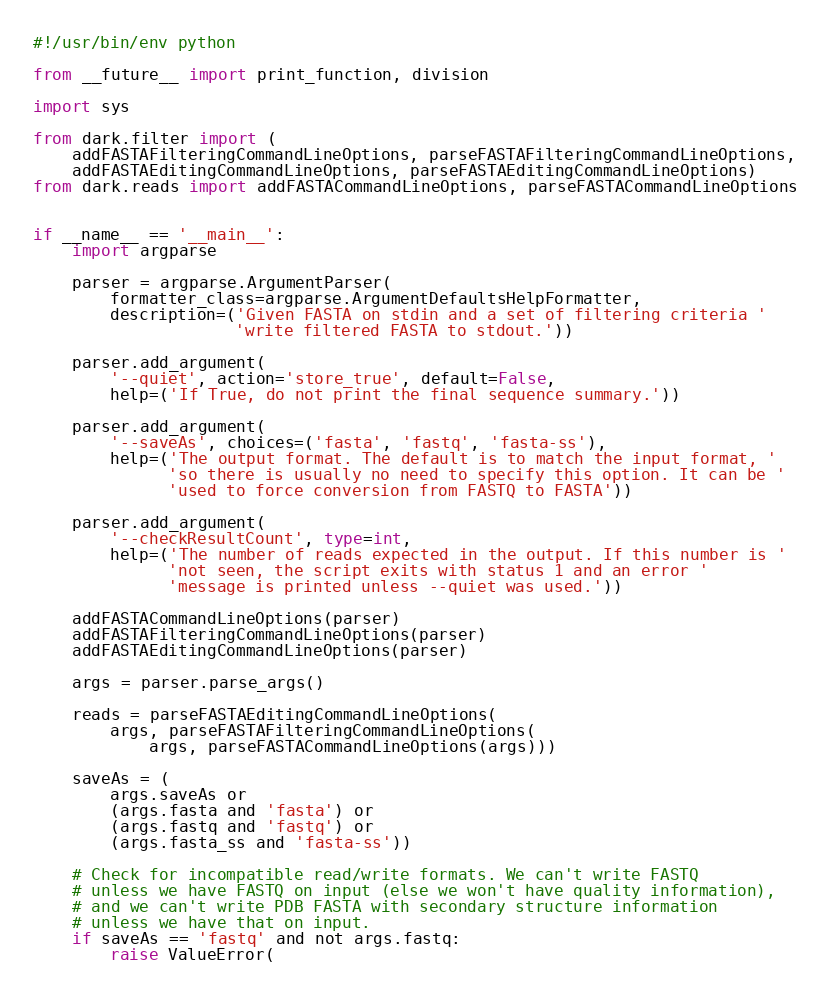<code> <loc_0><loc_0><loc_500><loc_500><_Python_>#!/usr/bin/env python

from __future__ import print_function, division

import sys

from dark.filter import (
    addFASTAFilteringCommandLineOptions, parseFASTAFilteringCommandLineOptions,
    addFASTAEditingCommandLineOptions, parseFASTAEditingCommandLineOptions)
from dark.reads import addFASTACommandLineOptions, parseFASTACommandLineOptions


if __name__ == '__main__':
    import argparse

    parser = argparse.ArgumentParser(
        formatter_class=argparse.ArgumentDefaultsHelpFormatter,
        description=('Given FASTA on stdin and a set of filtering criteria '
                     'write filtered FASTA to stdout.'))

    parser.add_argument(
        '--quiet', action='store_true', default=False,
        help=('If True, do not print the final sequence summary.'))

    parser.add_argument(
        '--saveAs', choices=('fasta', 'fastq', 'fasta-ss'),
        help=('The output format. The default is to match the input format, '
              'so there is usually no need to specify this option. It can be '
              'used to force conversion from FASTQ to FASTA'))

    parser.add_argument(
        '--checkResultCount', type=int,
        help=('The number of reads expected in the output. If this number is '
              'not seen, the script exits with status 1 and an error '
              'message is printed unless --quiet was used.'))

    addFASTACommandLineOptions(parser)
    addFASTAFilteringCommandLineOptions(parser)
    addFASTAEditingCommandLineOptions(parser)

    args = parser.parse_args()

    reads = parseFASTAEditingCommandLineOptions(
        args, parseFASTAFilteringCommandLineOptions(
            args, parseFASTACommandLineOptions(args)))

    saveAs = (
        args.saveAs or
        (args.fasta and 'fasta') or
        (args.fastq and 'fastq') or
        (args.fasta_ss and 'fasta-ss'))

    # Check for incompatible read/write formats. We can't write FASTQ
    # unless we have FASTQ on input (else we won't have quality information),
    # and we can't write PDB FASTA with secondary structure information
    # unless we have that on input.
    if saveAs == 'fastq' and not args.fastq:
        raise ValueError(</code> 